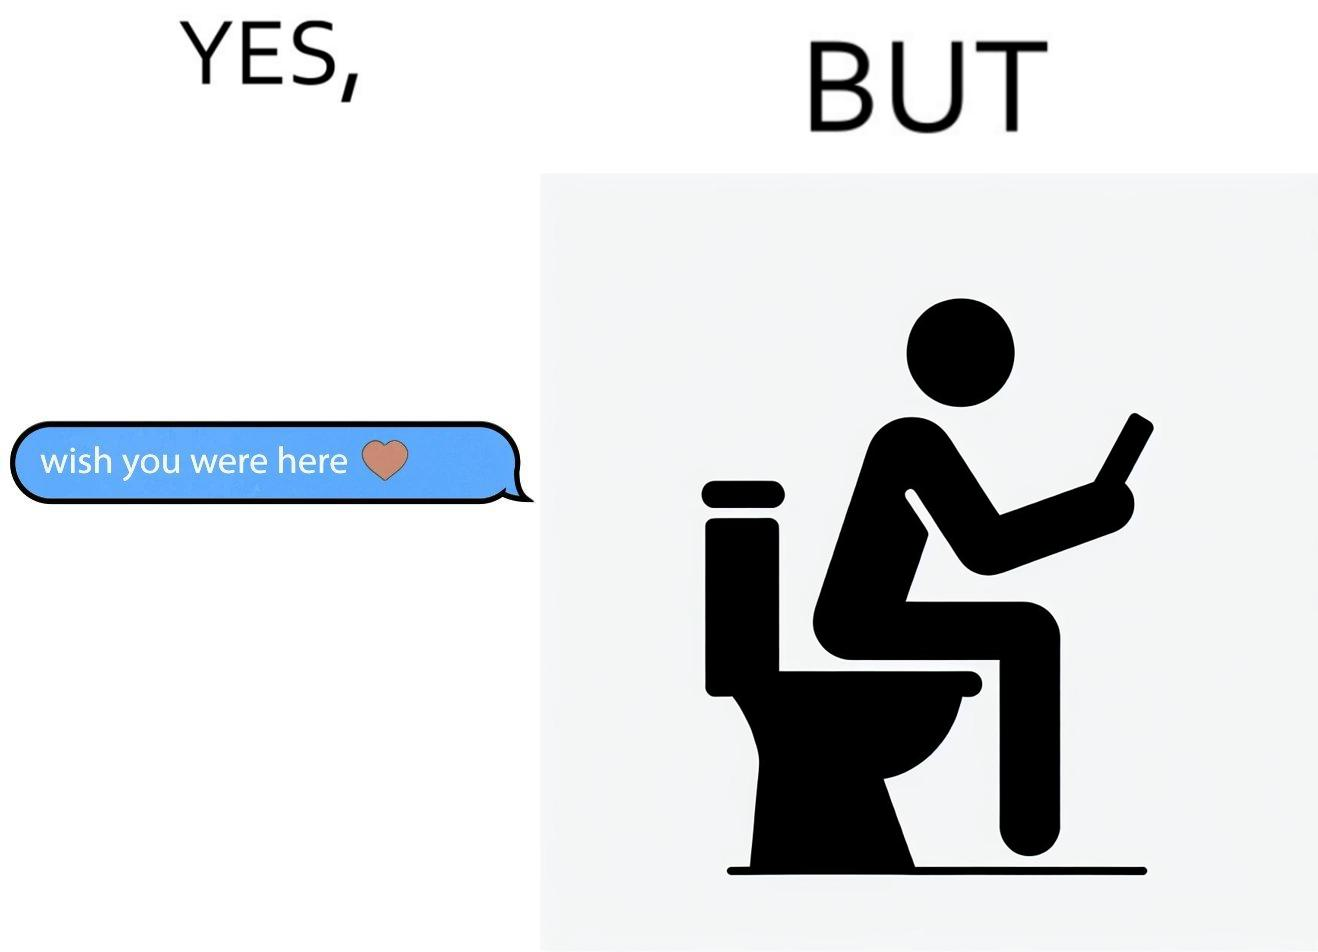Is this image satirical or non-satirical? Yes, this image is satirical. 